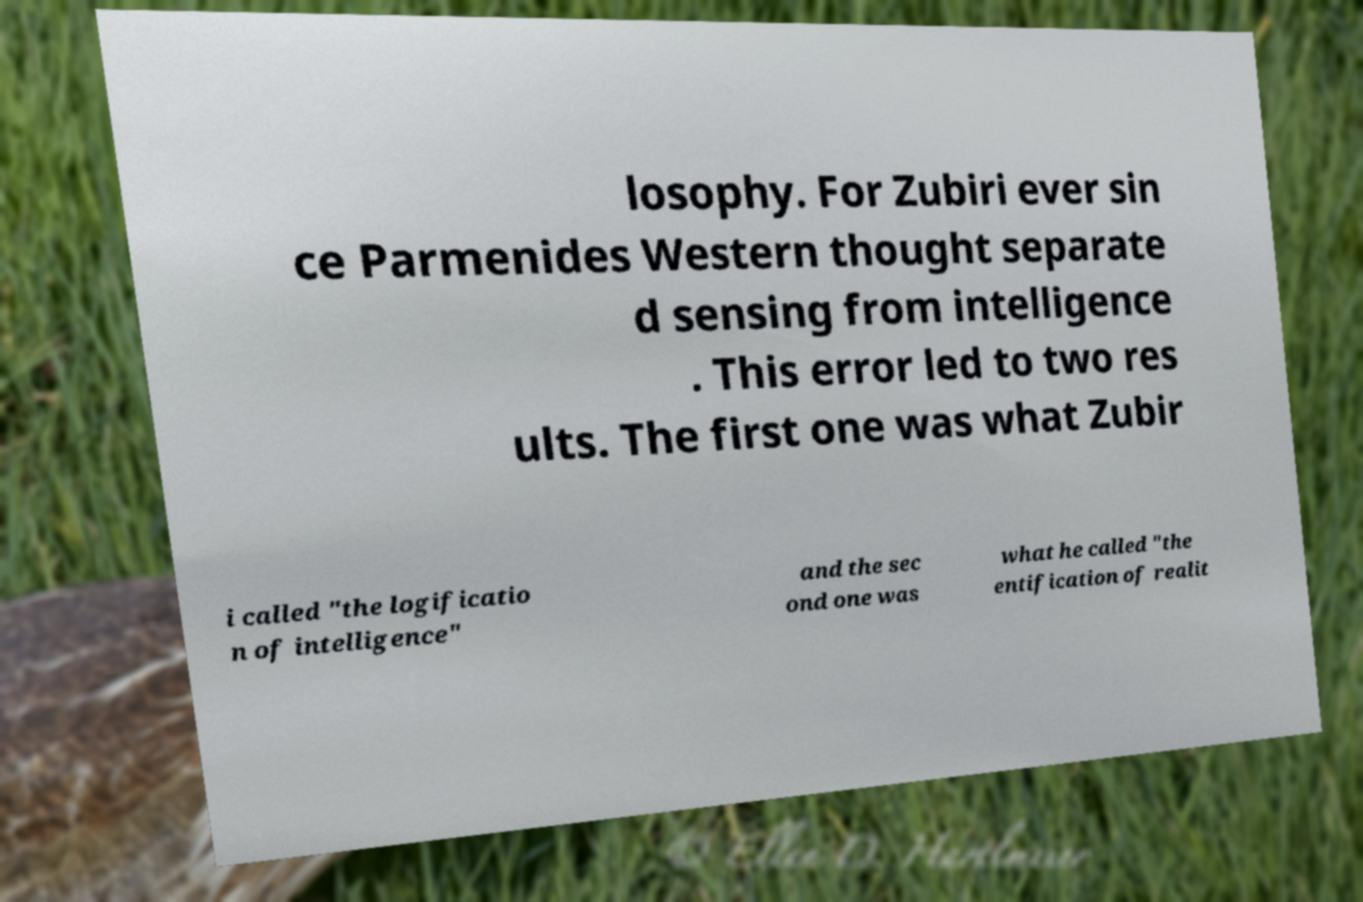I need the written content from this picture converted into text. Can you do that? losophy. For Zubiri ever sin ce Parmenides Western thought separate d sensing from intelligence . This error led to two res ults. The first one was what Zubir i called "the logificatio n of intelligence" and the sec ond one was what he called "the entification of realit 